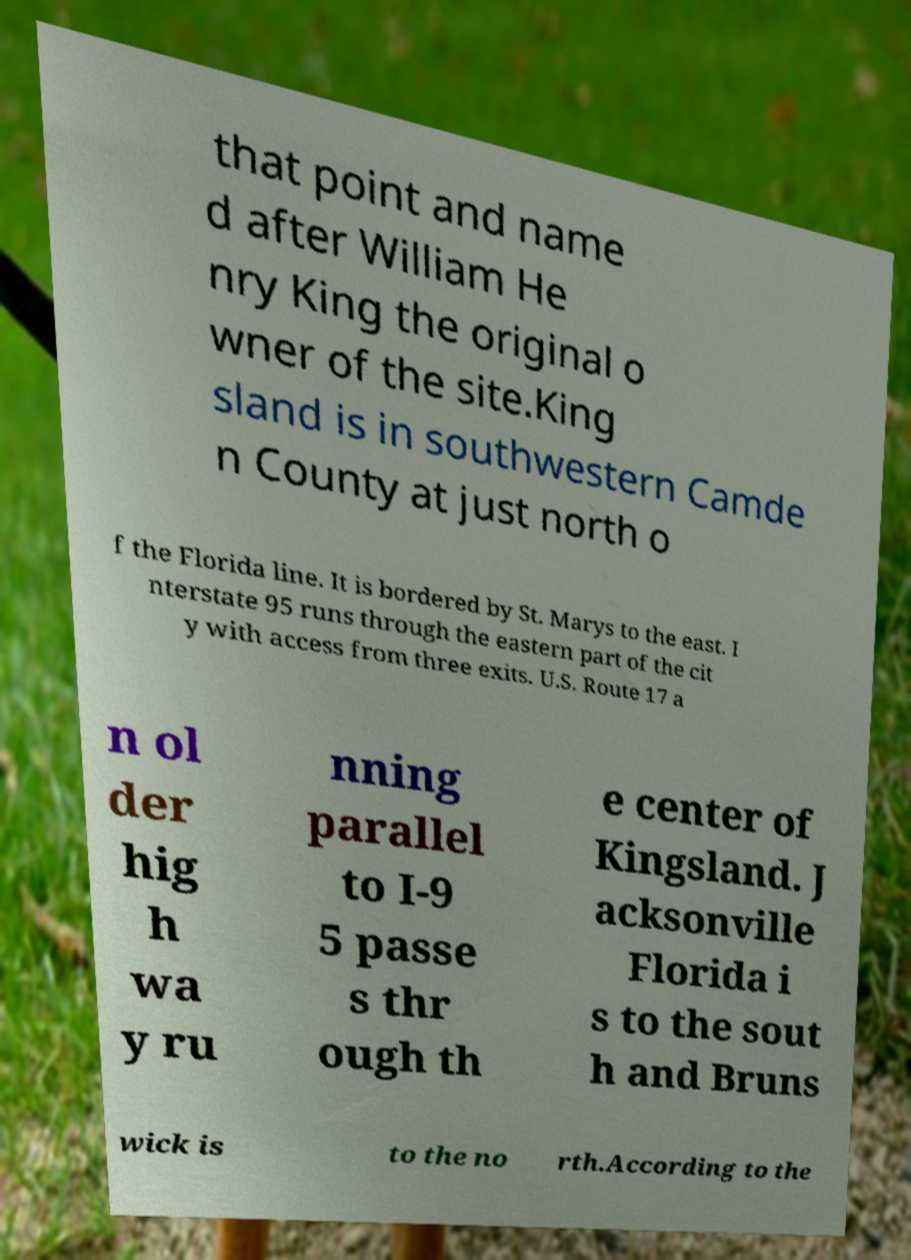For documentation purposes, I need the text within this image transcribed. Could you provide that? that point and name d after William He nry King the original o wner of the site.King sland is in southwestern Camde n County at just north o f the Florida line. It is bordered by St. Marys to the east. I nterstate 95 runs through the eastern part of the cit y with access from three exits. U.S. Route 17 a n ol der hig h wa y ru nning parallel to I-9 5 passe s thr ough th e center of Kingsland. J acksonville Florida i s to the sout h and Bruns wick is to the no rth.According to the 